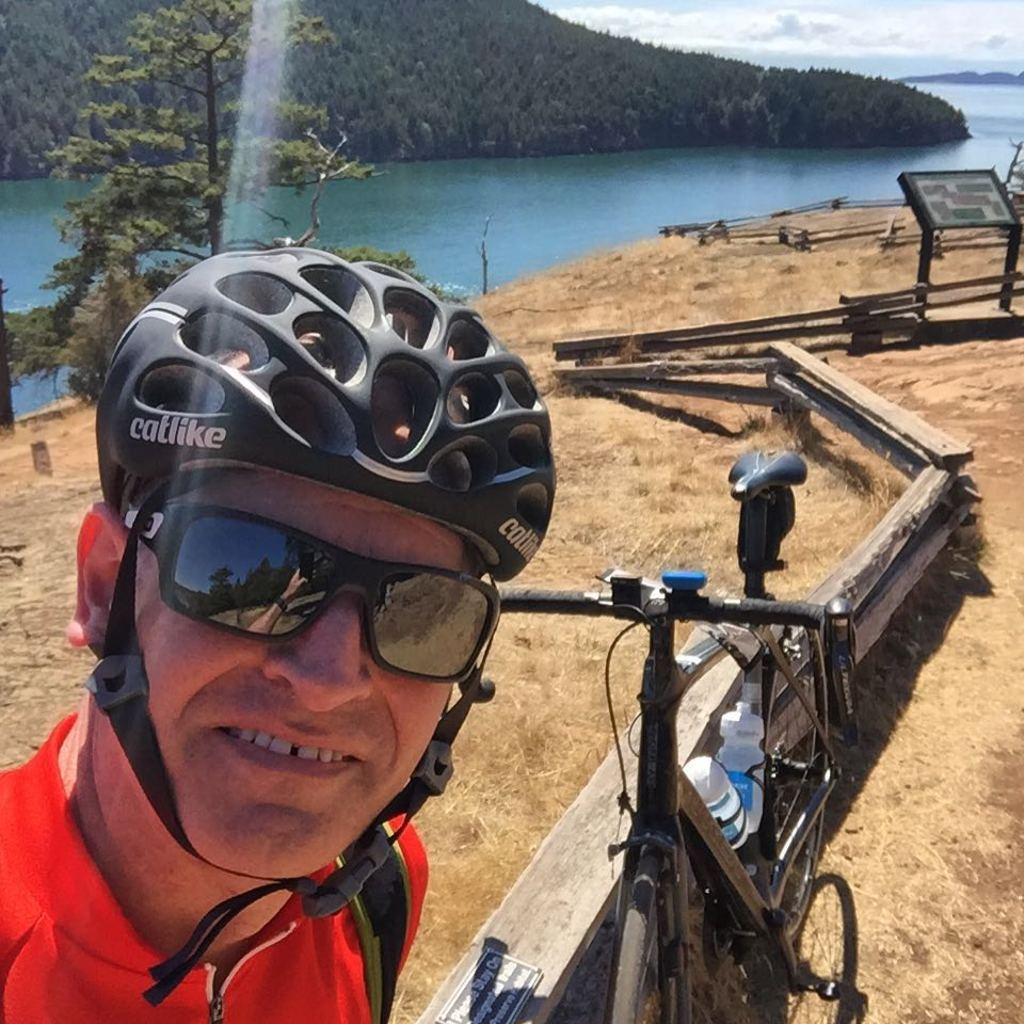What can be seen in the image? There is a person in the image. What is the person wearing on their head? The person is wearing a helmet. What else is the person wearing? The person is wearing shades. What can be seen in the background of the image? There is a bicycle, a fence, grass, water, trees, and the sky in the background of the image. Can you describe the setting of the image? The image appears to be set outdoors, with a natural environment featuring grass, water, and trees. What other objects are present in the background of the image? There are other objects in the background of the image, but their specific details are not mentioned in the provided facts. What type of wool is being spun by the donkey in the image? There is no donkey or wool present in the image. 